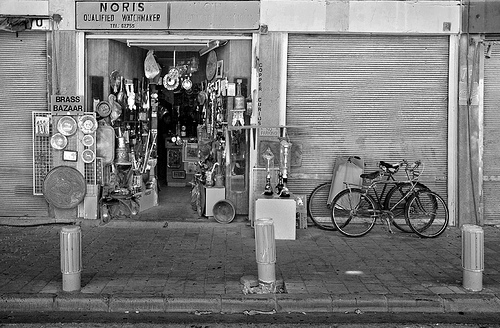How many trucks are shown? 0 